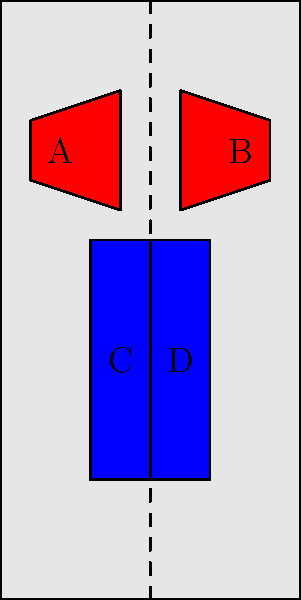In the human anatomy diagram above, which pair of muscle groups demonstrates perfect bilateral symmetry across the central axis? To determine which pair of muscle groups demonstrates perfect bilateral symmetry, we need to analyze each pair:

1. Pair A and B (Pectoral muscles):
   - These are located in the upper chest area.
   - They appear to be mirror images of each other across the central dashed line.
   - Their shape, size, and position are identical when reflected.

2. Pair C and D (Abdominal muscles):
   - These are located in the lower torso area.
   - They also appear to be mirror images of each other across the central dashed line.
   - Their shape, size, and position are identical when reflected.

3. Comparing A-B with C-D:
   - Both pairs demonstrate bilateral symmetry.
   - The central dashed line acts as the axis of symmetry for both pairs.
   - There are no visible differences in shape, size, or position when comparing left and right sides for either pair.

4. Conclusion:
   - Both pairs (A-B and C-D) demonstrate perfect bilateral symmetry across the central axis.
   - In the context of bodybuilding and aesthetics, this symmetry is crucial for a balanced and appealing physique.

Therefore, both pairs of muscle groups in the diagram demonstrate perfect bilateral symmetry across the central axis.
Answer: Both pairs (A-B and C-D) 